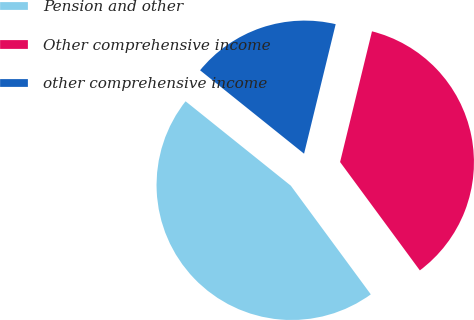Convert chart to OTSL. <chart><loc_0><loc_0><loc_500><loc_500><pie_chart><fcel>Pension and other<fcel>Other comprehensive income<fcel>other comprehensive income<nl><fcel>45.86%<fcel>36.09%<fcel>18.05%<nl></chart> 